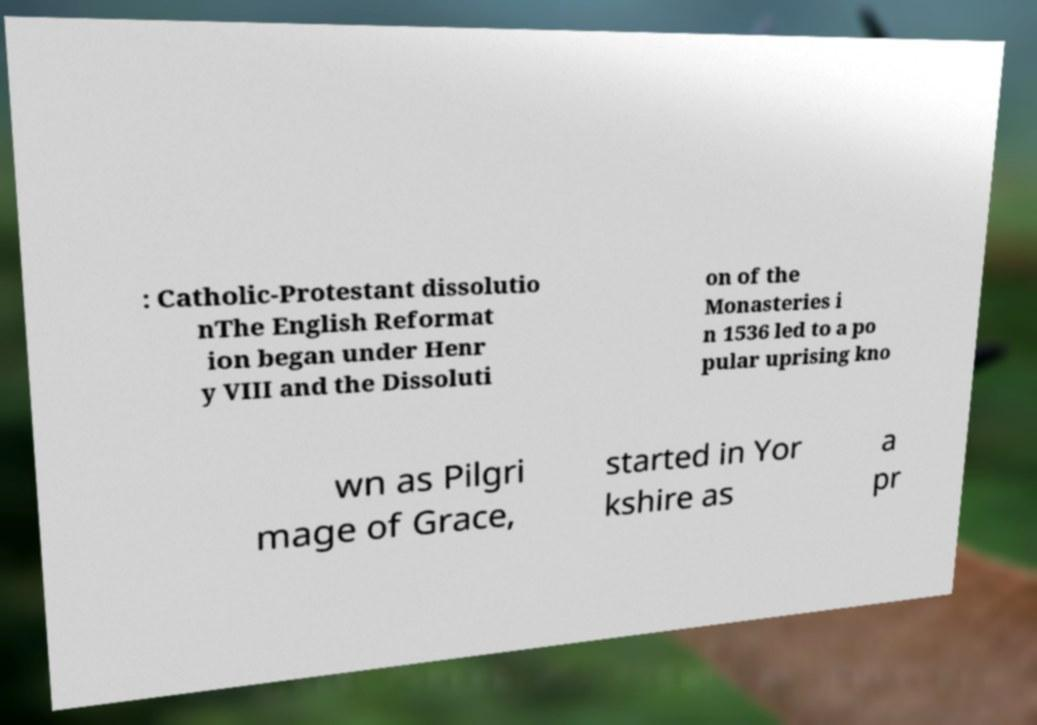What messages or text are displayed in this image? I need them in a readable, typed format. : Catholic-Protestant dissolutio nThe English Reformat ion began under Henr y VIII and the Dissoluti on of the Monasteries i n 1536 led to a po pular uprising kno wn as Pilgri mage of Grace, started in Yor kshire as a pr 